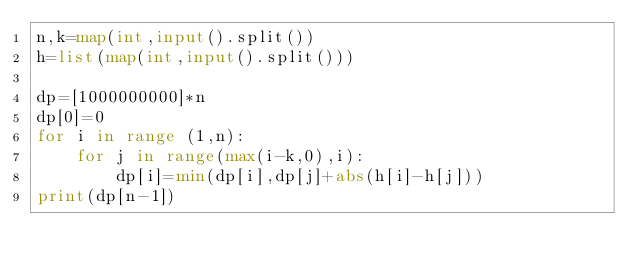<code> <loc_0><loc_0><loc_500><loc_500><_Python_>n,k=map(int,input().split())
h=list(map(int,input().split()))

dp=[1000000000]*n
dp[0]=0
for i in range (1,n):
    for j in range(max(i-k,0),i):
        dp[i]=min(dp[i],dp[j]+abs(h[i]-h[j]))
print(dp[n-1])</code> 